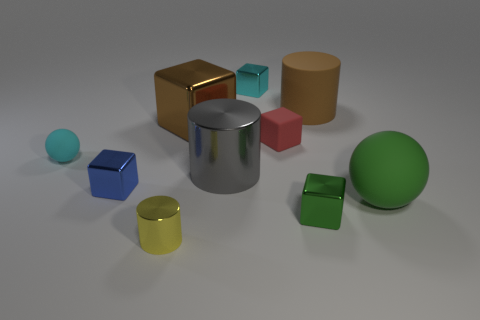Subtract 1 cylinders. How many cylinders are left? 2 Subtract all small metal blocks. How many blocks are left? 2 Subtract all red cubes. How many cubes are left? 4 Subtract all purple cubes. Subtract all blue spheres. How many cubes are left? 5 Subtract all spheres. How many objects are left? 8 Subtract all tiny cyan cubes. Subtract all small cubes. How many objects are left? 5 Add 4 red matte blocks. How many red matte blocks are left? 5 Add 9 big green metallic cubes. How many big green metallic cubes exist? 9 Subtract 0 yellow balls. How many objects are left? 10 